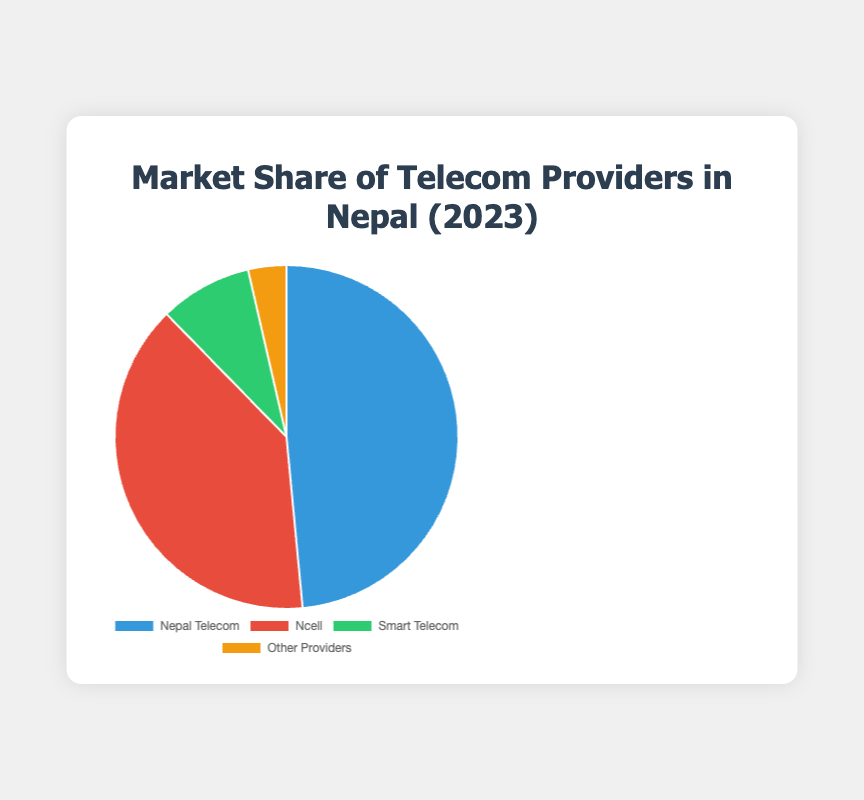What is the market share of Ncell? From the pie chart, identify the segment labeled "Ncell" and read the corresponding percentage.
Answer: 39.2% Which telecom provider has the highest market share? Compare the market shares of all the providers shown in the chart. The segment labeled "Nepal Telecom" has the highest value.
Answer: Nepal Telecom What is the total market share of providers other than Nepal Telecom? Sum the market shares of Ncell, Smart Telecom, and Other Providers: 39.2% + 8.7% + 3.6% = 51.5%.
Answer: 51.5% By how much does Nepal Telecom's market share exceed that of Smart Telecom? Subtract Smart Telecom's market share from Nepal Telecom's: 48.5% - 8.7% = 39.8%.
Answer: 39.8% What is the difference in market share between Ncell and Other Providers? Subtract Other Providers' market share from Ncell's: 39.2% - 3.6% = 35.6%.
Answer: 35.6% What is the combined market share of Nepal Telecom and Ncell? Add the market shares of Nepal Telecom and Ncell: 48.5% + 39.2% = 87.7%.
Answer: 87.7% What color represents the market share of Smart Telecom? Identify the segment labeled "Smart Telecom" in the chart and determine its color, which is specified as green.
Answer: Green How does the market share of Other Providers compare to Smart Telecom? Compare the percentages of "Other Providers" and "Smart Telecom" segments in the chart. Smart Telecom has a higher market share at 8.7% compared to Other Providers at 3.6%.
Answer: Smart Telecom has a higher market share Which two providers together make up more than 80% of the market? Check the market shares of different combinations of two providers. Nepal Telecom and Ncell together have a combined market share of 48.5% + 39.2% = 87.7%, which is more than 80%.
Answer: Nepal Telecom and Ncell 